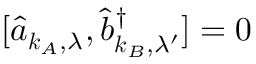<formula> <loc_0><loc_0><loc_500><loc_500>[ \hat { a } _ { k _ { A } , \lambda } , \hat { b } _ { k _ { B } , \lambda ^ { \prime } } ^ { \dagger } ] = 0</formula> 